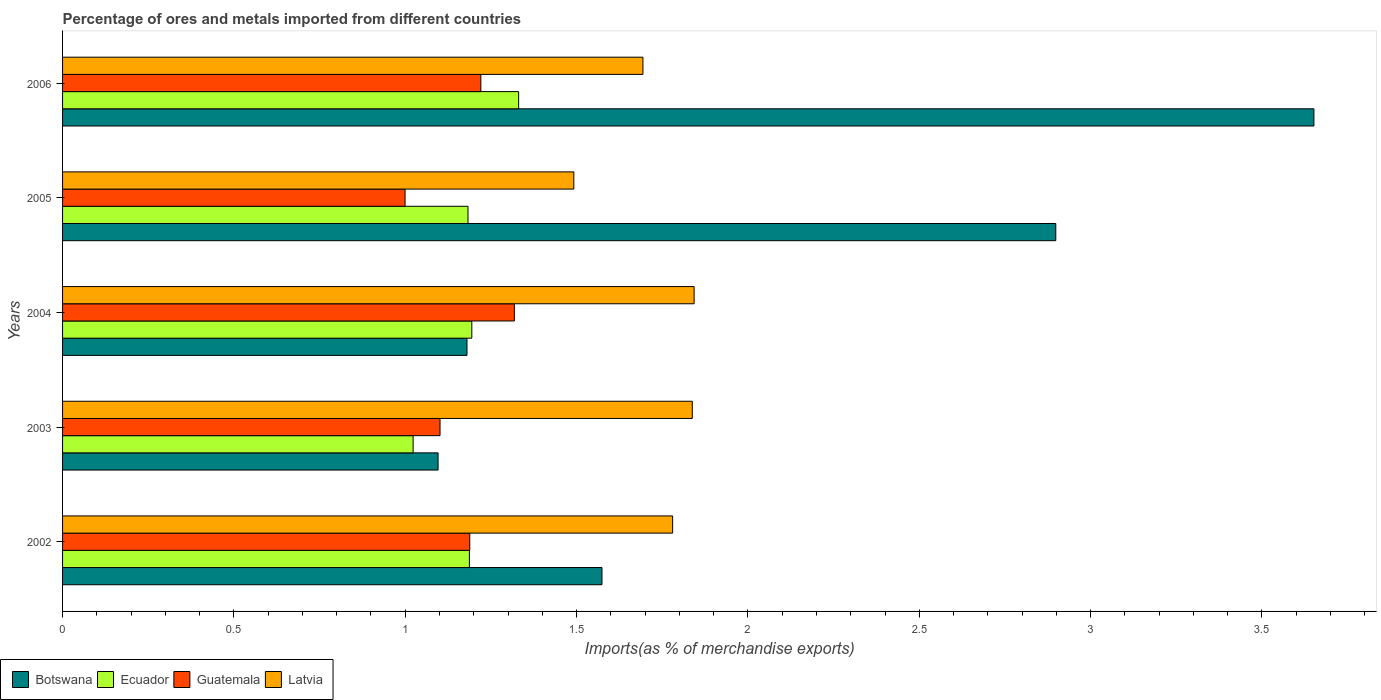Are the number of bars per tick equal to the number of legend labels?
Keep it short and to the point. Yes. How many bars are there on the 3rd tick from the top?
Make the answer very short. 4. What is the label of the 1st group of bars from the top?
Provide a succinct answer. 2006. In how many cases, is the number of bars for a given year not equal to the number of legend labels?
Offer a very short reply. 0. What is the percentage of imports to different countries in Botswana in 2006?
Provide a succinct answer. 3.65. Across all years, what is the maximum percentage of imports to different countries in Latvia?
Your response must be concise. 1.84. Across all years, what is the minimum percentage of imports to different countries in Ecuador?
Provide a short and direct response. 1.02. In which year was the percentage of imports to different countries in Ecuador maximum?
Make the answer very short. 2006. In which year was the percentage of imports to different countries in Guatemala minimum?
Offer a terse response. 2005. What is the total percentage of imports to different countries in Botswana in the graph?
Offer a terse response. 10.4. What is the difference between the percentage of imports to different countries in Guatemala in 2002 and that in 2005?
Provide a succinct answer. 0.19. What is the difference between the percentage of imports to different countries in Guatemala in 2005 and the percentage of imports to different countries in Botswana in 2002?
Give a very brief answer. -0.57. What is the average percentage of imports to different countries in Latvia per year?
Your answer should be compact. 1.73. In the year 2004, what is the difference between the percentage of imports to different countries in Latvia and percentage of imports to different countries in Guatemala?
Your answer should be compact. 0.52. In how many years, is the percentage of imports to different countries in Botswana greater than 3.4 %?
Provide a succinct answer. 1. What is the ratio of the percentage of imports to different countries in Ecuador in 2004 to that in 2006?
Keep it short and to the point. 0.9. What is the difference between the highest and the second highest percentage of imports to different countries in Guatemala?
Provide a succinct answer. 0.1. What is the difference between the highest and the lowest percentage of imports to different countries in Botswana?
Keep it short and to the point. 2.56. Is it the case that in every year, the sum of the percentage of imports to different countries in Botswana and percentage of imports to different countries in Guatemala is greater than the sum of percentage of imports to different countries in Ecuador and percentage of imports to different countries in Latvia?
Your answer should be very brief. No. What does the 2nd bar from the top in 2005 represents?
Make the answer very short. Guatemala. What does the 4th bar from the bottom in 2005 represents?
Provide a short and direct response. Latvia. Is it the case that in every year, the sum of the percentage of imports to different countries in Ecuador and percentage of imports to different countries in Botswana is greater than the percentage of imports to different countries in Guatemala?
Offer a terse response. Yes. How many bars are there?
Offer a terse response. 20. Are all the bars in the graph horizontal?
Provide a succinct answer. Yes. How many years are there in the graph?
Your answer should be very brief. 5. What is the difference between two consecutive major ticks on the X-axis?
Provide a succinct answer. 0.5. Are the values on the major ticks of X-axis written in scientific E-notation?
Provide a succinct answer. No. Does the graph contain any zero values?
Offer a very short reply. No. Does the graph contain grids?
Ensure brevity in your answer.  No. Where does the legend appear in the graph?
Your answer should be compact. Bottom left. How many legend labels are there?
Offer a very short reply. 4. How are the legend labels stacked?
Provide a succinct answer. Horizontal. What is the title of the graph?
Provide a short and direct response. Percentage of ores and metals imported from different countries. Does "Middle income" appear as one of the legend labels in the graph?
Make the answer very short. No. What is the label or title of the X-axis?
Your answer should be compact. Imports(as % of merchandise exports). What is the label or title of the Y-axis?
Ensure brevity in your answer.  Years. What is the Imports(as % of merchandise exports) in Botswana in 2002?
Offer a very short reply. 1.57. What is the Imports(as % of merchandise exports) of Ecuador in 2002?
Ensure brevity in your answer.  1.19. What is the Imports(as % of merchandise exports) in Guatemala in 2002?
Provide a succinct answer. 1.19. What is the Imports(as % of merchandise exports) of Latvia in 2002?
Provide a succinct answer. 1.78. What is the Imports(as % of merchandise exports) of Botswana in 2003?
Provide a succinct answer. 1.1. What is the Imports(as % of merchandise exports) of Ecuador in 2003?
Ensure brevity in your answer.  1.02. What is the Imports(as % of merchandise exports) of Guatemala in 2003?
Your response must be concise. 1.1. What is the Imports(as % of merchandise exports) in Latvia in 2003?
Your answer should be very brief. 1.84. What is the Imports(as % of merchandise exports) in Botswana in 2004?
Your answer should be very brief. 1.18. What is the Imports(as % of merchandise exports) in Ecuador in 2004?
Provide a short and direct response. 1.19. What is the Imports(as % of merchandise exports) in Guatemala in 2004?
Your answer should be compact. 1.32. What is the Imports(as % of merchandise exports) in Latvia in 2004?
Keep it short and to the point. 1.84. What is the Imports(as % of merchandise exports) in Botswana in 2005?
Provide a succinct answer. 2.9. What is the Imports(as % of merchandise exports) of Ecuador in 2005?
Keep it short and to the point. 1.18. What is the Imports(as % of merchandise exports) in Guatemala in 2005?
Provide a short and direct response. 1. What is the Imports(as % of merchandise exports) in Latvia in 2005?
Your answer should be compact. 1.49. What is the Imports(as % of merchandise exports) of Botswana in 2006?
Ensure brevity in your answer.  3.65. What is the Imports(as % of merchandise exports) of Ecuador in 2006?
Ensure brevity in your answer.  1.33. What is the Imports(as % of merchandise exports) of Guatemala in 2006?
Keep it short and to the point. 1.22. What is the Imports(as % of merchandise exports) of Latvia in 2006?
Give a very brief answer. 1.69. Across all years, what is the maximum Imports(as % of merchandise exports) of Botswana?
Provide a short and direct response. 3.65. Across all years, what is the maximum Imports(as % of merchandise exports) in Ecuador?
Ensure brevity in your answer.  1.33. Across all years, what is the maximum Imports(as % of merchandise exports) of Guatemala?
Offer a terse response. 1.32. Across all years, what is the maximum Imports(as % of merchandise exports) of Latvia?
Offer a terse response. 1.84. Across all years, what is the minimum Imports(as % of merchandise exports) of Botswana?
Offer a terse response. 1.1. Across all years, what is the minimum Imports(as % of merchandise exports) of Ecuador?
Ensure brevity in your answer.  1.02. Across all years, what is the minimum Imports(as % of merchandise exports) in Guatemala?
Provide a short and direct response. 1. Across all years, what is the minimum Imports(as % of merchandise exports) of Latvia?
Give a very brief answer. 1.49. What is the total Imports(as % of merchandise exports) in Botswana in the graph?
Ensure brevity in your answer.  10.4. What is the total Imports(as % of merchandise exports) in Ecuador in the graph?
Offer a very short reply. 5.92. What is the total Imports(as % of merchandise exports) of Guatemala in the graph?
Your answer should be very brief. 5.83. What is the total Imports(as % of merchandise exports) of Latvia in the graph?
Provide a short and direct response. 8.65. What is the difference between the Imports(as % of merchandise exports) in Botswana in 2002 and that in 2003?
Provide a succinct answer. 0.48. What is the difference between the Imports(as % of merchandise exports) of Ecuador in 2002 and that in 2003?
Provide a succinct answer. 0.16. What is the difference between the Imports(as % of merchandise exports) of Guatemala in 2002 and that in 2003?
Give a very brief answer. 0.09. What is the difference between the Imports(as % of merchandise exports) in Latvia in 2002 and that in 2003?
Your answer should be compact. -0.06. What is the difference between the Imports(as % of merchandise exports) of Botswana in 2002 and that in 2004?
Provide a succinct answer. 0.39. What is the difference between the Imports(as % of merchandise exports) in Ecuador in 2002 and that in 2004?
Give a very brief answer. -0.01. What is the difference between the Imports(as % of merchandise exports) in Guatemala in 2002 and that in 2004?
Give a very brief answer. -0.13. What is the difference between the Imports(as % of merchandise exports) in Latvia in 2002 and that in 2004?
Make the answer very short. -0.06. What is the difference between the Imports(as % of merchandise exports) of Botswana in 2002 and that in 2005?
Ensure brevity in your answer.  -1.32. What is the difference between the Imports(as % of merchandise exports) of Ecuador in 2002 and that in 2005?
Keep it short and to the point. 0. What is the difference between the Imports(as % of merchandise exports) in Guatemala in 2002 and that in 2005?
Your response must be concise. 0.19. What is the difference between the Imports(as % of merchandise exports) of Latvia in 2002 and that in 2005?
Offer a terse response. 0.29. What is the difference between the Imports(as % of merchandise exports) of Botswana in 2002 and that in 2006?
Keep it short and to the point. -2.08. What is the difference between the Imports(as % of merchandise exports) of Ecuador in 2002 and that in 2006?
Offer a terse response. -0.14. What is the difference between the Imports(as % of merchandise exports) of Guatemala in 2002 and that in 2006?
Keep it short and to the point. -0.03. What is the difference between the Imports(as % of merchandise exports) in Latvia in 2002 and that in 2006?
Make the answer very short. 0.09. What is the difference between the Imports(as % of merchandise exports) of Botswana in 2003 and that in 2004?
Provide a short and direct response. -0.08. What is the difference between the Imports(as % of merchandise exports) of Ecuador in 2003 and that in 2004?
Keep it short and to the point. -0.17. What is the difference between the Imports(as % of merchandise exports) of Guatemala in 2003 and that in 2004?
Ensure brevity in your answer.  -0.22. What is the difference between the Imports(as % of merchandise exports) of Latvia in 2003 and that in 2004?
Make the answer very short. -0.01. What is the difference between the Imports(as % of merchandise exports) in Botswana in 2003 and that in 2005?
Ensure brevity in your answer.  -1.8. What is the difference between the Imports(as % of merchandise exports) of Ecuador in 2003 and that in 2005?
Offer a terse response. -0.16. What is the difference between the Imports(as % of merchandise exports) in Guatemala in 2003 and that in 2005?
Provide a succinct answer. 0.1. What is the difference between the Imports(as % of merchandise exports) of Latvia in 2003 and that in 2005?
Your answer should be compact. 0.35. What is the difference between the Imports(as % of merchandise exports) in Botswana in 2003 and that in 2006?
Make the answer very short. -2.56. What is the difference between the Imports(as % of merchandise exports) in Ecuador in 2003 and that in 2006?
Your answer should be compact. -0.31. What is the difference between the Imports(as % of merchandise exports) of Guatemala in 2003 and that in 2006?
Keep it short and to the point. -0.12. What is the difference between the Imports(as % of merchandise exports) of Latvia in 2003 and that in 2006?
Make the answer very short. 0.14. What is the difference between the Imports(as % of merchandise exports) in Botswana in 2004 and that in 2005?
Ensure brevity in your answer.  -1.72. What is the difference between the Imports(as % of merchandise exports) of Ecuador in 2004 and that in 2005?
Your response must be concise. 0.01. What is the difference between the Imports(as % of merchandise exports) in Guatemala in 2004 and that in 2005?
Offer a terse response. 0.32. What is the difference between the Imports(as % of merchandise exports) in Latvia in 2004 and that in 2005?
Give a very brief answer. 0.35. What is the difference between the Imports(as % of merchandise exports) of Botswana in 2004 and that in 2006?
Make the answer very short. -2.47. What is the difference between the Imports(as % of merchandise exports) in Ecuador in 2004 and that in 2006?
Offer a very short reply. -0.14. What is the difference between the Imports(as % of merchandise exports) of Guatemala in 2004 and that in 2006?
Offer a very short reply. 0.1. What is the difference between the Imports(as % of merchandise exports) in Latvia in 2004 and that in 2006?
Offer a terse response. 0.15. What is the difference between the Imports(as % of merchandise exports) in Botswana in 2005 and that in 2006?
Offer a terse response. -0.75. What is the difference between the Imports(as % of merchandise exports) of Ecuador in 2005 and that in 2006?
Make the answer very short. -0.15. What is the difference between the Imports(as % of merchandise exports) of Guatemala in 2005 and that in 2006?
Your answer should be very brief. -0.22. What is the difference between the Imports(as % of merchandise exports) of Latvia in 2005 and that in 2006?
Provide a succinct answer. -0.2. What is the difference between the Imports(as % of merchandise exports) of Botswana in 2002 and the Imports(as % of merchandise exports) of Ecuador in 2003?
Provide a short and direct response. 0.55. What is the difference between the Imports(as % of merchandise exports) in Botswana in 2002 and the Imports(as % of merchandise exports) in Guatemala in 2003?
Ensure brevity in your answer.  0.47. What is the difference between the Imports(as % of merchandise exports) in Botswana in 2002 and the Imports(as % of merchandise exports) in Latvia in 2003?
Offer a very short reply. -0.26. What is the difference between the Imports(as % of merchandise exports) of Ecuador in 2002 and the Imports(as % of merchandise exports) of Guatemala in 2003?
Ensure brevity in your answer.  0.09. What is the difference between the Imports(as % of merchandise exports) of Ecuador in 2002 and the Imports(as % of merchandise exports) of Latvia in 2003?
Your answer should be compact. -0.65. What is the difference between the Imports(as % of merchandise exports) in Guatemala in 2002 and the Imports(as % of merchandise exports) in Latvia in 2003?
Provide a succinct answer. -0.65. What is the difference between the Imports(as % of merchandise exports) in Botswana in 2002 and the Imports(as % of merchandise exports) in Ecuador in 2004?
Keep it short and to the point. 0.38. What is the difference between the Imports(as % of merchandise exports) in Botswana in 2002 and the Imports(as % of merchandise exports) in Guatemala in 2004?
Provide a short and direct response. 0.26. What is the difference between the Imports(as % of merchandise exports) in Botswana in 2002 and the Imports(as % of merchandise exports) in Latvia in 2004?
Make the answer very short. -0.27. What is the difference between the Imports(as % of merchandise exports) in Ecuador in 2002 and the Imports(as % of merchandise exports) in Guatemala in 2004?
Keep it short and to the point. -0.13. What is the difference between the Imports(as % of merchandise exports) in Ecuador in 2002 and the Imports(as % of merchandise exports) in Latvia in 2004?
Offer a very short reply. -0.66. What is the difference between the Imports(as % of merchandise exports) in Guatemala in 2002 and the Imports(as % of merchandise exports) in Latvia in 2004?
Give a very brief answer. -0.65. What is the difference between the Imports(as % of merchandise exports) of Botswana in 2002 and the Imports(as % of merchandise exports) of Ecuador in 2005?
Keep it short and to the point. 0.39. What is the difference between the Imports(as % of merchandise exports) of Botswana in 2002 and the Imports(as % of merchandise exports) of Guatemala in 2005?
Provide a succinct answer. 0.57. What is the difference between the Imports(as % of merchandise exports) of Botswana in 2002 and the Imports(as % of merchandise exports) of Latvia in 2005?
Offer a terse response. 0.08. What is the difference between the Imports(as % of merchandise exports) in Ecuador in 2002 and the Imports(as % of merchandise exports) in Guatemala in 2005?
Give a very brief answer. 0.19. What is the difference between the Imports(as % of merchandise exports) of Ecuador in 2002 and the Imports(as % of merchandise exports) of Latvia in 2005?
Offer a very short reply. -0.3. What is the difference between the Imports(as % of merchandise exports) in Guatemala in 2002 and the Imports(as % of merchandise exports) in Latvia in 2005?
Your answer should be very brief. -0.3. What is the difference between the Imports(as % of merchandise exports) of Botswana in 2002 and the Imports(as % of merchandise exports) of Ecuador in 2006?
Your answer should be compact. 0.24. What is the difference between the Imports(as % of merchandise exports) of Botswana in 2002 and the Imports(as % of merchandise exports) of Guatemala in 2006?
Provide a short and direct response. 0.35. What is the difference between the Imports(as % of merchandise exports) of Botswana in 2002 and the Imports(as % of merchandise exports) of Latvia in 2006?
Ensure brevity in your answer.  -0.12. What is the difference between the Imports(as % of merchandise exports) of Ecuador in 2002 and the Imports(as % of merchandise exports) of Guatemala in 2006?
Your answer should be compact. -0.03. What is the difference between the Imports(as % of merchandise exports) of Ecuador in 2002 and the Imports(as % of merchandise exports) of Latvia in 2006?
Ensure brevity in your answer.  -0.51. What is the difference between the Imports(as % of merchandise exports) in Guatemala in 2002 and the Imports(as % of merchandise exports) in Latvia in 2006?
Give a very brief answer. -0.51. What is the difference between the Imports(as % of merchandise exports) of Botswana in 2003 and the Imports(as % of merchandise exports) of Ecuador in 2004?
Offer a very short reply. -0.1. What is the difference between the Imports(as % of merchandise exports) in Botswana in 2003 and the Imports(as % of merchandise exports) in Guatemala in 2004?
Provide a short and direct response. -0.22. What is the difference between the Imports(as % of merchandise exports) in Botswana in 2003 and the Imports(as % of merchandise exports) in Latvia in 2004?
Provide a short and direct response. -0.75. What is the difference between the Imports(as % of merchandise exports) of Ecuador in 2003 and the Imports(as % of merchandise exports) of Guatemala in 2004?
Your response must be concise. -0.3. What is the difference between the Imports(as % of merchandise exports) in Ecuador in 2003 and the Imports(as % of merchandise exports) in Latvia in 2004?
Offer a terse response. -0.82. What is the difference between the Imports(as % of merchandise exports) in Guatemala in 2003 and the Imports(as % of merchandise exports) in Latvia in 2004?
Keep it short and to the point. -0.74. What is the difference between the Imports(as % of merchandise exports) in Botswana in 2003 and the Imports(as % of merchandise exports) in Ecuador in 2005?
Your answer should be very brief. -0.09. What is the difference between the Imports(as % of merchandise exports) of Botswana in 2003 and the Imports(as % of merchandise exports) of Guatemala in 2005?
Your answer should be very brief. 0.1. What is the difference between the Imports(as % of merchandise exports) of Botswana in 2003 and the Imports(as % of merchandise exports) of Latvia in 2005?
Make the answer very short. -0.4. What is the difference between the Imports(as % of merchandise exports) in Ecuador in 2003 and the Imports(as % of merchandise exports) in Guatemala in 2005?
Offer a terse response. 0.02. What is the difference between the Imports(as % of merchandise exports) of Ecuador in 2003 and the Imports(as % of merchandise exports) of Latvia in 2005?
Make the answer very short. -0.47. What is the difference between the Imports(as % of merchandise exports) in Guatemala in 2003 and the Imports(as % of merchandise exports) in Latvia in 2005?
Your answer should be compact. -0.39. What is the difference between the Imports(as % of merchandise exports) in Botswana in 2003 and the Imports(as % of merchandise exports) in Ecuador in 2006?
Make the answer very short. -0.24. What is the difference between the Imports(as % of merchandise exports) of Botswana in 2003 and the Imports(as % of merchandise exports) of Guatemala in 2006?
Provide a short and direct response. -0.12. What is the difference between the Imports(as % of merchandise exports) of Botswana in 2003 and the Imports(as % of merchandise exports) of Latvia in 2006?
Offer a terse response. -0.6. What is the difference between the Imports(as % of merchandise exports) in Ecuador in 2003 and the Imports(as % of merchandise exports) in Guatemala in 2006?
Your response must be concise. -0.2. What is the difference between the Imports(as % of merchandise exports) in Ecuador in 2003 and the Imports(as % of merchandise exports) in Latvia in 2006?
Your response must be concise. -0.67. What is the difference between the Imports(as % of merchandise exports) of Guatemala in 2003 and the Imports(as % of merchandise exports) of Latvia in 2006?
Your answer should be compact. -0.59. What is the difference between the Imports(as % of merchandise exports) in Botswana in 2004 and the Imports(as % of merchandise exports) in Ecuador in 2005?
Make the answer very short. -0. What is the difference between the Imports(as % of merchandise exports) in Botswana in 2004 and the Imports(as % of merchandise exports) in Guatemala in 2005?
Give a very brief answer. 0.18. What is the difference between the Imports(as % of merchandise exports) of Botswana in 2004 and the Imports(as % of merchandise exports) of Latvia in 2005?
Ensure brevity in your answer.  -0.31. What is the difference between the Imports(as % of merchandise exports) of Ecuador in 2004 and the Imports(as % of merchandise exports) of Guatemala in 2005?
Provide a succinct answer. 0.19. What is the difference between the Imports(as % of merchandise exports) of Ecuador in 2004 and the Imports(as % of merchandise exports) of Latvia in 2005?
Provide a succinct answer. -0.3. What is the difference between the Imports(as % of merchandise exports) of Guatemala in 2004 and the Imports(as % of merchandise exports) of Latvia in 2005?
Offer a very short reply. -0.17. What is the difference between the Imports(as % of merchandise exports) in Botswana in 2004 and the Imports(as % of merchandise exports) in Ecuador in 2006?
Offer a terse response. -0.15. What is the difference between the Imports(as % of merchandise exports) of Botswana in 2004 and the Imports(as % of merchandise exports) of Guatemala in 2006?
Offer a terse response. -0.04. What is the difference between the Imports(as % of merchandise exports) in Botswana in 2004 and the Imports(as % of merchandise exports) in Latvia in 2006?
Ensure brevity in your answer.  -0.51. What is the difference between the Imports(as % of merchandise exports) in Ecuador in 2004 and the Imports(as % of merchandise exports) in Guatemala in 2006?
Ensure brevity in your answer.  -0.03. What is the difference between the Imports(as % of merchandise exports) in Ecuador in 2004 and the Imports(as % of merchandise exports) in Latvia in 2006?
Keep it short and to the point. -0.5. What is the difference between the Imports(as % of merchandise exports) of Guatemala in 2004 and the Imports(as % of merchandise exports) of Latvia in 2006?
Offer a very short reply. -0.38. What is the difference between the Imports(as % of merchandise exports) of Botswana in 2005 and the Imports(as % of merchandise exports) of Ecuador in 2006?
Provide a short and direct response. 1.57. What is the difference between the Imports(as % of merchandise exports) in Botswana in 2005 and the Imports(as % of merchandise exports) in Guatemala in 2006?
Keep it short and to the point. 1.68. What is the difference between the Imports(as % of merchandise exports) of Botswana in 2005 and the Imports(as % of merchandise exports) of Latvia in 2006?
Ensure brevity in your answer.  1.2. What is the difference between the Imports(as % of merchandise exports) of Ecuador in 2005 and the Imports(as % of merchandise exports) of Guatemala in 2006?
Provide a succinct answer. -0.04. What is the difference between the Imports(as % of merchandise exports) in Ecuador in 2005 and the Imports(as % of merchandise exports) in Latvia in 2006?
Your answer should be compact. -0.51. What is the difference between the Imports(as % of merchandise exports) of Guatemala in 2005 and the Imports(as % of merchandise exports) of Latvia in 2006?
Provide a short and direct response. -0.69. What is the average Imports(as % of merchandise exports) of Botswana per year?
Your answer should be very brief. 2.08. What is the average Imports(as % of merchandise exports) in Ecuador per year?
Offer a very short reply. 1.18. What is the average Imports(as % of merchandise exports) in Guatemala per year?
Make the answer very short. 1.17. What is the average Imports(as % of merchandise exports) in Latvia per year?
Your answer should be very brief. 1.73. In the year 2002, what is the difference between the Imports(as % of merchandise exports) in Botswana and Imports(as % of merchandise exports) in Ecuador?
Make the answer very short. 0.39. In the year 2002, what is the difference between the Imports(as % of merchandise exports) of Botswana and Imports(as % of merchandise exports) of Guatemala?
Provide a short and direct response. 0.39. In the year 2002, what is the difference between the Imports(as % of merchandise exports) in Botswana and Imports(as % of merchandise exports) in Latvia?
Give a very brief answer. -0.21. In the year 2002, what is the difference between the Imports(as % of merchandise exports) in Ecuador and Imports(as % of merchandise exports) in Guatemala?
Provide a short and direct response. -0. In the year 2002, what is the difference between the Imports(as % of merchandise exports) of Ecuador and Imports(as % of merchandise exports) of Latvia?
Provide a short and direct response. -0.59. In the year 2002, what is the difference between the Imports(as % of merchandise exports) of Guatemala and Imports(as % of merchandise exports) of Latvia?
Ensure brevity in your answer.  -0.59. In the year 2003, what is the difference between the Imports(as % of merchandise exports) in Botswana and Imports(as % of merchandise exports) in Ecuador?
Ensure brevity in your answer.  0.07. In the year 2003, what is the difference between the Imports(as % of merchandise exports) of Botswana and Imports(as % of merchandise exports) of Guatemala?
Offer a terse response. -0.01. In the year 2003, what is the difference between the Imports(as % of merchandise exports) of Botswana and Imports(as % of merchandise exports) of Latvia?
Provide a succinct answer. -0.74. In the year 2003, what is the difference between the Imports(as % of merchandise exports) in Ecuador and Imports(as % of merchandise exports) in Guatemala?
Keep it short and to the point. -0.08. In the year 2003, what is the difference between the Imports(as % of merchandise exports) in Ecuador and Imports(as % of merchandise exports) in Latvia?
Your answer should be compact. -0.81. In the year 2003, what is the difference between the Imports(as % of merchandise exports) in Guatemala and Imports(as % of merchandise exports) in Latvia?
Provide a succinct answer. -0.74. In the year 2004, what is the difference between the Imports(as % of merchandise exports) of Botswana and Imports(as % of merchandise exports) of Ecuador?
Your response must be concise. -0.01. In the year 2004, what is the difference between the Imports(as % of merchandise exports) in Botswana and Imports(as % of merchandise exports) in Guatemala?
Provide a short and direct response. -0.14. In the year 2004, what is the difference between the Imports(as % of merchandise exports) in Botswana and Imports(as % of merchandise exports) in Latvia?
Your answer should be compact. -0.66. In the year 2004, what is the difference between the Imports(as % of merchandise exports) in Ecuador and Imports(as % of merchandise exports) in Guatemala?
Keep it short and to the point. -0.12. In the year 2004, what is the difference between the Imports(as % of merchandise exports) of Ecuador and Imports(as % of merchandise exports) of Latvia?
Give a very brief answer. -0.65. In the year 2004, what is the difference between the Imports(as % of merchandise exports) in Guatemala and Imports(as % of merchandise exports) in Latvia?
Provide a succinct answer. -0.52. In the year 2005, what is the difference between the Imports(as % of merchandise exports) of Botswana and Imports(as % of merchandise exports) of Ecuador?
Give a very brief answer. 1.72. In the year 2005, what is the difference between the Imports(as % of merchandise exports) in Botswana and Imports(as % of merchandise exports) in Guatemala?
Make the answer very short. 1.9. In the year 2005, what is the difference between the Imports(as % of merchandise exports) in Botswana and Imports(as % of merchandise exports) in Latvia?
Make the answer very short. 1.41. In the year 2005, what is the difference between the Imports(as % of merchandise exports) in Ecuador and Imports(as % of merchandise exports) in Guatemala?
Provide a succinct answer. 0.18. In the year 2005, what is the difference between the Imports(as % of merchandise exports) in Ecuador and Imports(as % of merchandise exports) in Latvia?
Your answer should be compact. -0.31. In the year 2005, what is the difference between the Imports(as % of merchandise exports) in Guatemala and Imports(as % of merchandise exports) in Latvia?
Offer a very short reply. -0.49. In the year 2006, what is the difference between the Imports(as % of merchandise exports) in Botswana and Imports(as % of merchandise exports) in Ecuador?
Your answer should be very brief. 2.32. In the year 2006, what is the difference between the Imports(as % of merchandise exports) of Botswana and Imports(as % of merchandise exports) of Guatemala?
Your answer should be compact. 2.43. In the year 2006, what is the difference between the Imports(as % of merchandise exports) in Botswana and Imports(as % of merchandise exports) in Latvia?
Keep it short and to the point. 1.96. In the year 2006, what is the difference between the Imports(as % of merchandise exports) in Ecuador and Imports(as % of merchandise exports) in Guatemala?
Provide a succinct answer. 0.11. In the year 2006, what is the difference between the Imports(as % of merchandise exports) in Ecuador and Imports(as % of merchandise exports) in Latvia?
Offer a very short reply. -0.36. In the year 2006, what is the difference between the Imports(as % of merchandise exports) in Guatemala and Imports(as % of merchandise exports) in Latvia?
Your answer should be very brief. -0.47. What is the ratio of the Imports(as % of merchandise exports) of Botswana in 2002 to that in 2003?
Provide a succinct answer. 1.44. What is the ratio of the Imports(as % of merchandise exports) of Ecuador in 2002 to that in 2003?
Provide a succinct answer. 1.16. What is the ratio of the Imports(as % of merchandise exports) in Guatemala in 2002 to that in 2003?
Provide a succinct answer. 1.08. What is the ratio of the Imports(as % of merchandise exports) of Latvia in 2002 to that in 2003?
Your answer should be compact. 0.97. What is the ratio of the Imports(as % of merchandise exports) of Botswana in 2002 to that in 2004?
Make the answer very short. 1.33. What is the ratio of the Imports(as % of merchandise exports) of Guatemala in 2002 to that in 2004?
Make the answer very short. 0.9. What is the ratio of the Imports(as % of merchandise exports) in Latvia in 2002 to that in 2004?
Offer a terse response. 0.97. What is the ratio of the Imports(as % of merchandise exports) in Botswana in 2002 to that in 2005?
Your response must be concise. 0.54. What is the ratio of the Imports(as % of merchandise exports) in Guatemala in 2002 to that in 2005?
Your answer should be compact. 1.19. What is the ratio of the Imports(as % of merchandise exports) in Latvia in 2002 to that in 2005?
Keep it short and to the point. 1.19. What is the ratio of the Imports(as % of merchandise exports) in Botswana in 2002 to that in 2006?
Your answer should be very brief. 0.43. What is the ratio of the Imports(as % of merchandise exports) in Ecuador in 2002 to that in 2006?
Provide a short and direct response. 0.89. What is the ratio of the Imports(as % of merchandise exports) of Guatemala in 2002 to that in 2006?
Ensure brevity in your answer.  0.97. What is the ratio of the Imports(as % of merchandise exports) of Latvia in 2002 to that in 2006?
Offer a terse response. 1.05. What is the ratio of the Imports(as % of merchandise exports) of Botswana in 2003 to that in 2004?
Offer a terse response. 0.93. What is the ratio of the Imports(as % of merchandise exports) in Ecuador in 2003 to that in 2004?
Provide a short and direct response. 0.86. What is the ratio of the Imports(as % of merchandise exports) in Guatemala in 2003 to that in 2004?
Your answer should be compact. 0.84. What is the ratio of the Imports(as % of merchandise exports) of Botswana in 2003 to that in 2005?
Offer a very short reply. 0.38. What is the ratio of the Imports(as % of merchandise exports) in Ecuador in 2003 to that in 2005?
Give a very brief answer. 0.86. What is the ratio of the Imports(as % of merchandise exports) in Guatemala in 2003 to that in 2005?
Your answer should be very brief. 1.1. What is the ratio of the Imports(as % of merchandise exports) of Latvia in 2003 to that in 2005?
Your answer should be compact. 1.23. What is the ratio of the Imports(as % of merchandise exports) of Botswana in 2003 to that in 2006?
Give a very brief answer. 0.3. What is the ratio of the Imports(as % of merchandise exports) in Ecuador in 2003 to that in 2006?
Keep it short and to the point. 0.77. What is the ratio of the Imports(as % of merchandise exports) in Guatemala in 2003 to that in 2006?
Provide a succinct answer. 0.9. What is the ratio of the Imports(as % of merchandise exports) of Latvia in 2003 to that in 2006?
Your answer should be very brief. 1.08. What is the ratio of the Imports(as % of merchandise exports) in Botswana in 2004 to that in 2005?
Provide a succinct answer. 0.41. What is the ratio of the Imports(as % of merchandise exports) in Ecuador in 2004 to that in 2005?
Your response must be concise. 1.01. What is the ratio of the Imports(as % of merchandise exports) in Guatemala in 2004 to that in 2005?
Provide a succinct answer. 1.32. What is the ratio of the Imports(as % of merchandise exports) of Latvia in 2004 to that in 2005?
Your response must be concise. 1.24. What is the ratio of the Imports(as % of merchandise exports) of Botswana in 2004 to that in 2006?
Provide a succinct answer. 0.32. What is the ratio of the Imports(as % of merchandise exports) in Ecuador in 2004 to that in 2006?
Provide a succinct answer. 0.9. What is the ratio of the Imports(as % of merchandise exports) in Guatemala in 2004 to that in 2006?
Make the answer very short. 1.08. What is the ratio of the Imports(as % of merchandise exports) in Latvia in 2004 to that in 2006?
Your response must be concise. 1.09. What is the ratio of the Imports(as % of merchandise exports) in Botswana in 2005 to that in 2006?
Make the answer very short. 0.79. What is the ratio of the Imports(as % of merchandise exports) of Ecuador in 2005 to that in 2006?
Make the answer very short. 0.89. What is the ratio of the Imports(as % of merchandise exports) in Guatemala in 2005 to that in 2006?
Your response must be concise. 0.82. What is the ratio of the Imports(as % of merchandise exports) of Latvia in 2005 to that in 2006?
Keep it short and to the point. 0.88. What is the difference between the highest and the second highest Imports(as % of merchandise exports) of Botswana?
Keep it short and to the point. 0.75. What is the difference between the highest and the second highest Imports(as % of merchandise exports) in Ecuador?
Provide a succinct answer. 0.14. What is the difference between the highest and the second highest Imports(as % of merchandise exports) in Guatemala?
Keep it short and to the point. 0.1. What is the difference between the highest and the second highest Imports(as % of merchandise exports) of Latvia?
Your answer should be compact. 0.01. What is the difference between the highest and the lowest Imports(as % of merchandise exports) of Botswana?
Provide a succinct answer. 2.56. What is the difference between the highest and the lowest Imports(as % of merchandise exports) of Ecuador?
Give a very brief answer. 0.31. What is the difference between the highest and the lowest Imports(as % of merchandise exports) in Guatemala?
Offer a very short reply. 0.32. What is the difference between the highest and the lowest Imports(as % of merchandise exports) in Latvia?
Your response must be concise. 0.35. 